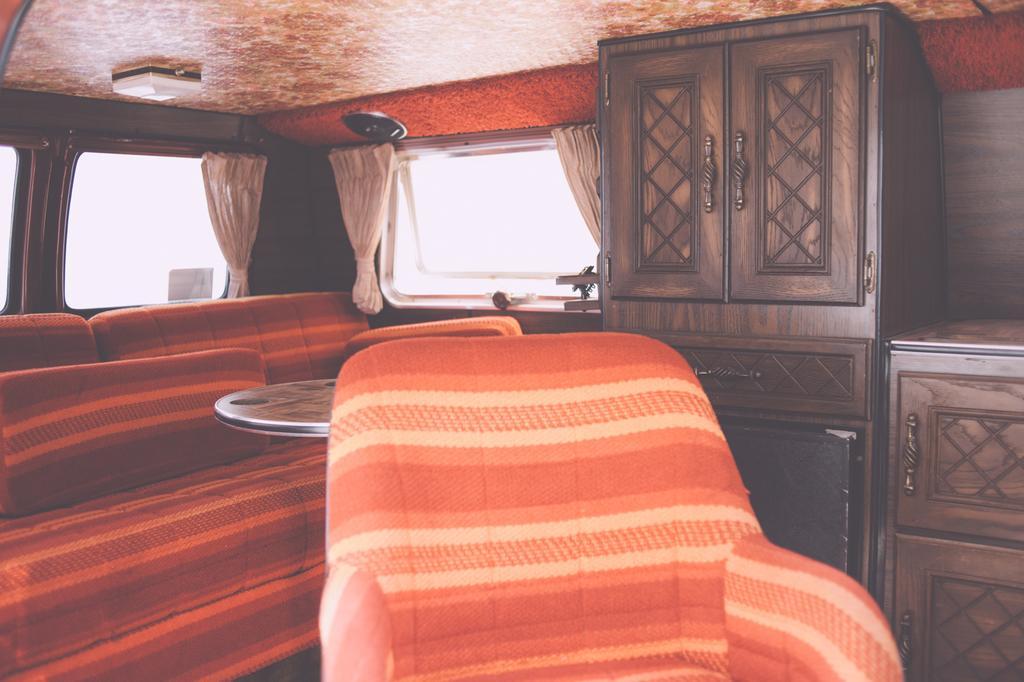How would you summarize this image in a sentence or two? This is the inside picture of the room. In this picture there is a sofa, chair, wooden cupboards and there are curtains. 